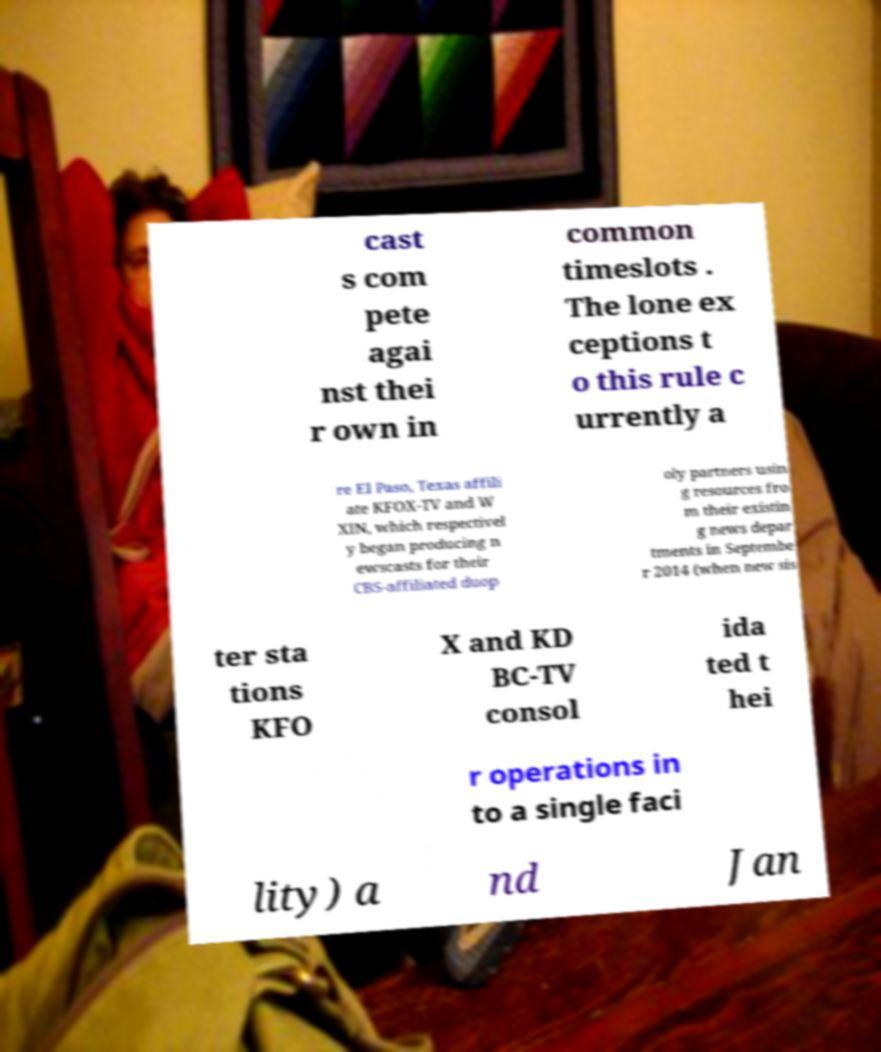Please read and relay the text visible in this image. What does it say? cast s com pete agai nst thei r own in common timeslots . The lone ex ceptions t o this rule c urrently a re El Paso, Texas affili ate KFOX-TV and W XIN, which respectivel y began producing n ewscasts for their CBS-affiliated duop oly partners usin g resources fro m their existin g news depar tments in Septembe r 2014 (when new sis ter sta tions KFO X and KD BC-TV consol ida ted t hei r operations in to a single faci lity) a nd Jan 